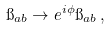<formula> <loc_0><loc_0><loc_500><loc_500>\i _ { a b } \rightarrow e ^ { i \phi } \i _ { a b } \, ,</formula> 